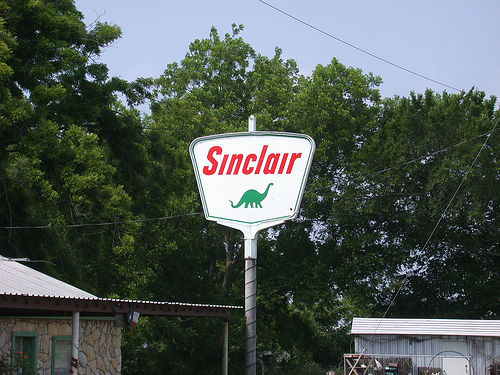<image>
Can you confirm if the house is behind the tree? No. The house is not behind the tree. From this viewpoint, the house appears to be positioned elsewhere in the scene. 